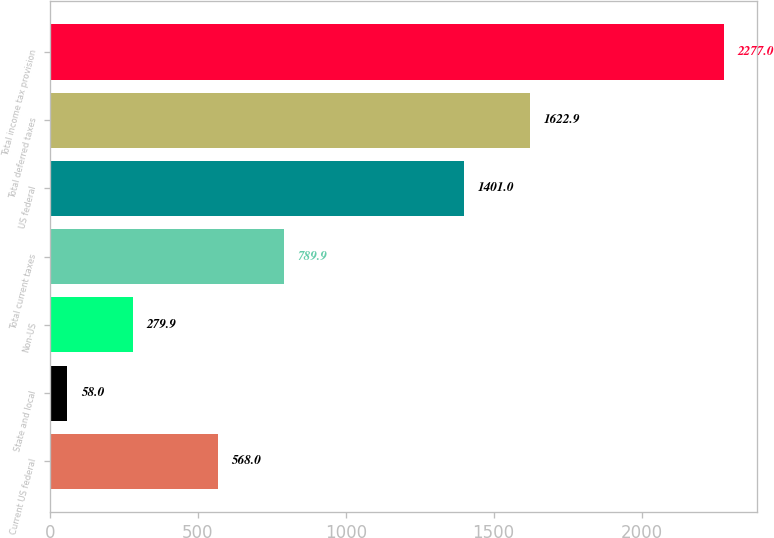Convert chart to OTSL. <chart><loc_0><loc_0><loc_500><loc_500><bar_chart><fcel>Current US federal<fcel>State and local<fcel>Non-US<fcel>Total current taxes<fcel>US federal<fcel>Total deferred taxes<fcel>Total income tax provision<nl><fcel>568<fcel>58<fcel>279.9<fcel>789.9<fcel>1401<fcel>1622.9<fcel>2277<nl></chart> 